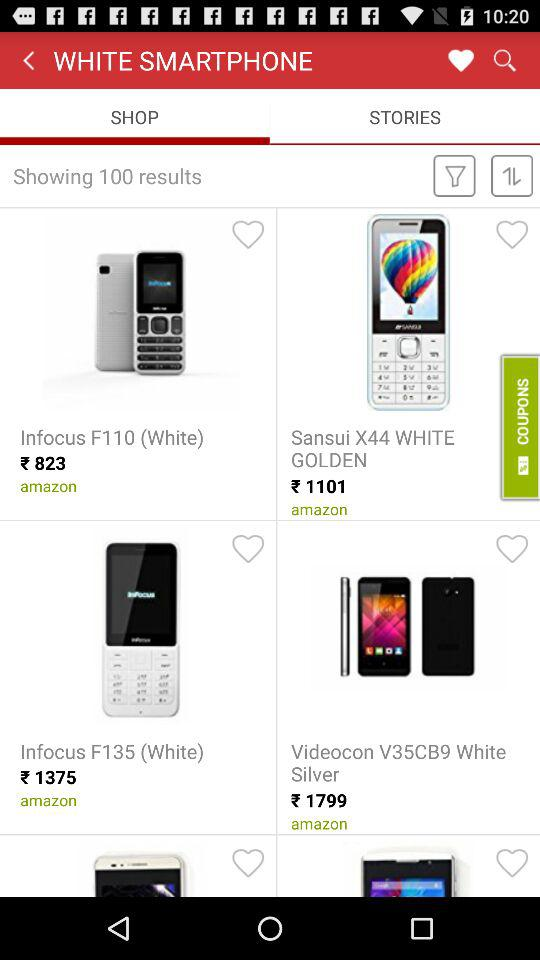How many results are shown? There are 100 results shown. 